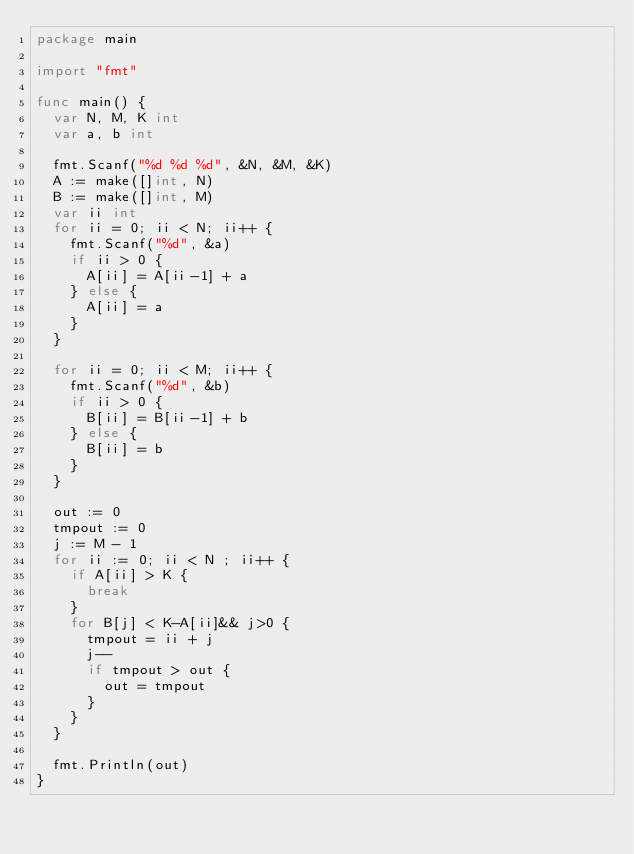<code> <loc_0><loc_0><loc_500><loc_500><_Go_>package main

import "fmt"

func main() {
	var N, M, K int
	var a, b int

	fmt.Scanf("%d %d %d", &N, &M, &K)
	A := make([]int, N)
	B := make([]int, M)
	var ii int
	for ii = 0; ii < N; ii++ {
		fmt.Scanf("%d", &a)
		if ii > 0 {
			A[ii] = A[ii-1] + a
		} else {
			A[ii] = a
		}
	}

	for ii = 0; ii < M; ii++ {
		fmt.Scanf("%d", &b)
		if ii > 0 {
			B[ii] = B[ii-1] + b
		} else {
			B[ii] = b
		}
	}

	out := 0
	tmpout := 0
	j := M - 1
	for ii := 0; ii < N ; ii++ {
		if A[ii] > K {
			break
		}
		for B[j] < K-A[ii]&& j>0 {
			tmpout = ii + j
			j--
			if tmpout > out {
				out = tmpout
			}
		}
	}

	fmt.Println(out)
}
</code> 